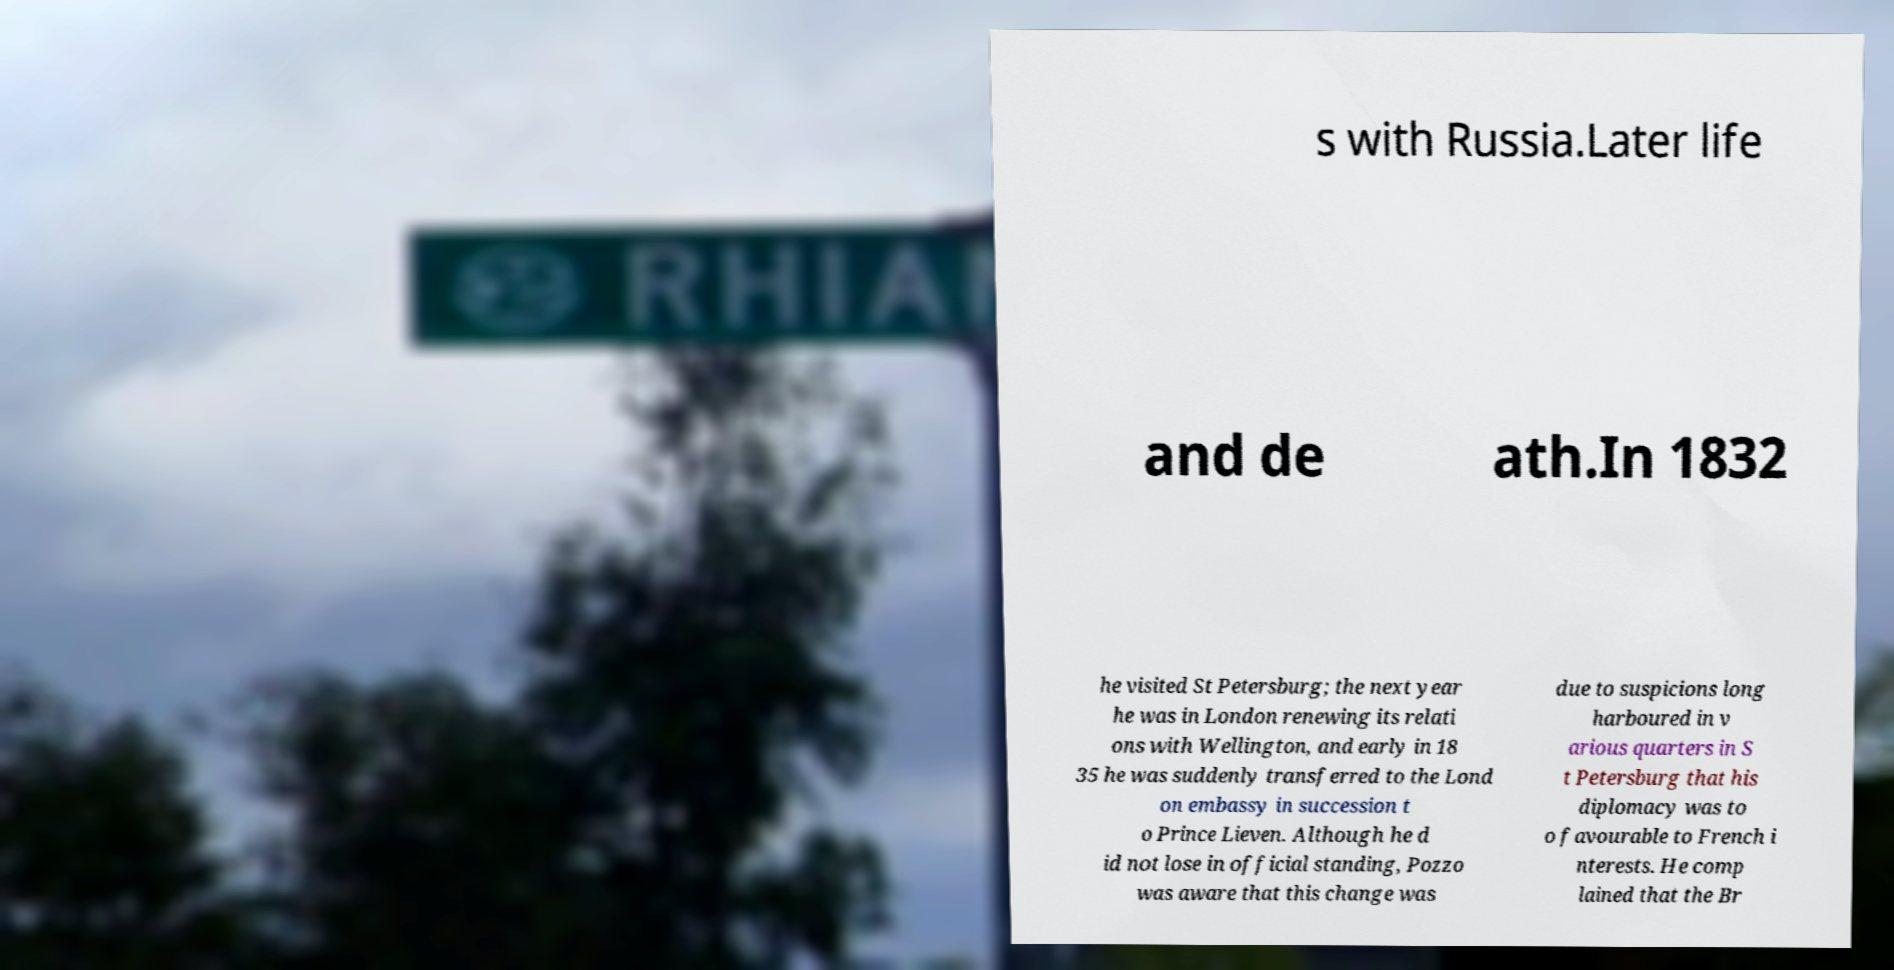Could you assist in decoding the text presented in this image and type it out clearly? s with Russia.Later life and de ath.In 1832 he visited St Petersburg; the next year he was in London renewing its relati ons with Wellington, and early in 18 35 he was suddenly transferred to the Lond on embassy in succession t o Prince Lieven. Although he d id not lose in official standing, Pozzo was aware that this change was due to suspicions long harboured in v arious quarters in S t Petersburg that his diplomacy was to o favourable to French i nterests. He comp lained that the Br 